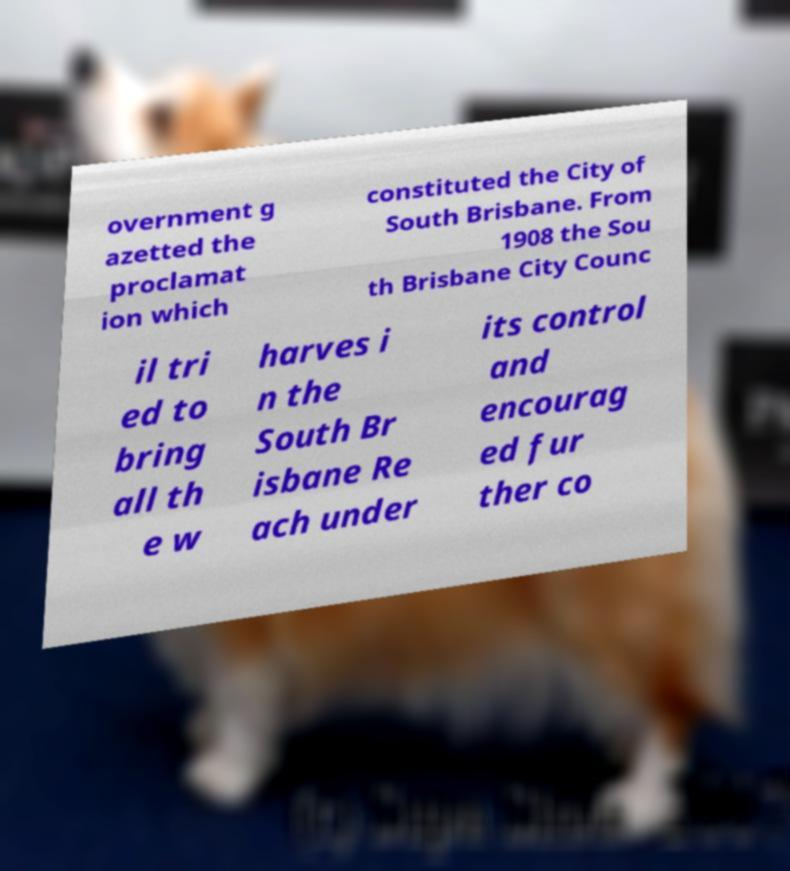Can you read and provide the text displayed in the image?This photo seems to have some interesting text. Can you extract and type it out for me? overnment g azetted the proclamat ion which constituted the City of South Brisbane. From 1908 the Sou th Brisbane City Counc il tri ed to bring all th e w harves i n the South Br isbane Re ach under its control and encourag ed fur ther co 